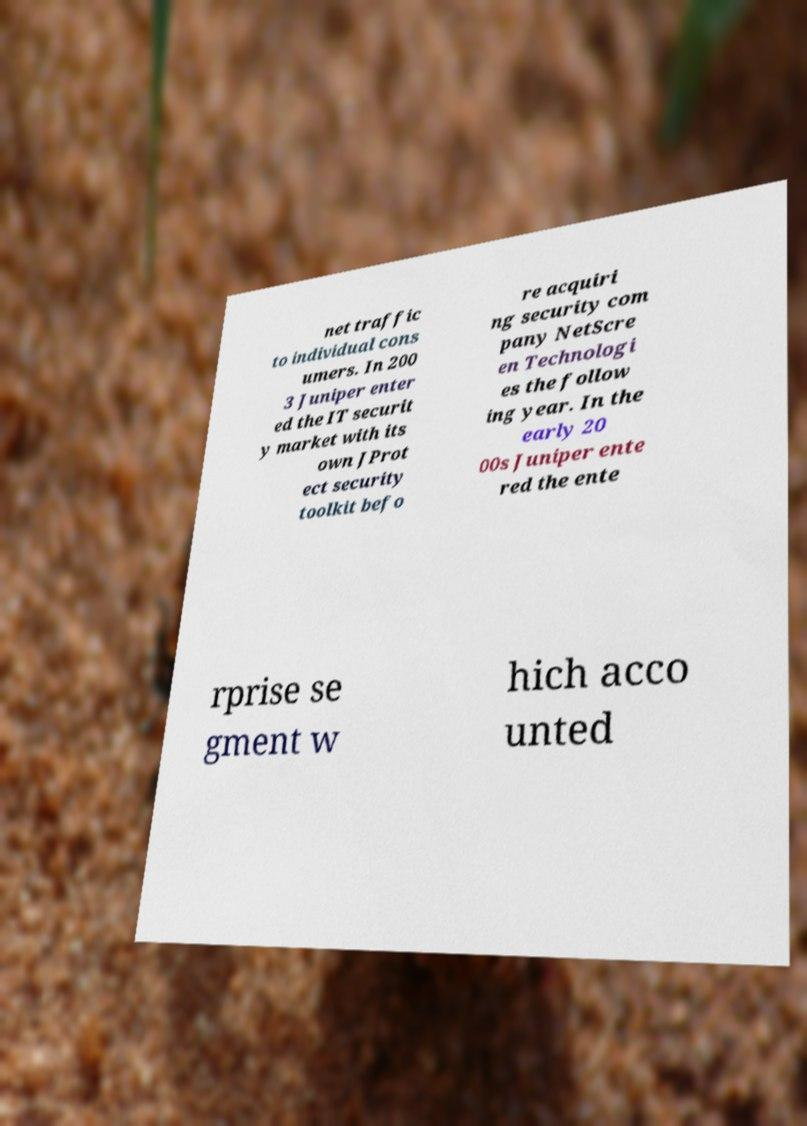What messages or text are displayed in this image? I need them in a readable, typed format. net traffic to individual cons umers. In 200 3 Juniper enter ed the IT securit y market with its own JProt ect security toolkit befo re acquiri ng security com pany NetScre en Technologi es the follow ing year. In the early 20 00s Juniper ente red the ente rprise se gment w hich acco unted 